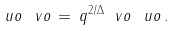Convert formula to latex. <formula><loc_0><loc_0><loc_500><loc_500>\ u o \, \ v o \, = \, q ^ { 2 / \Delta } \ v o \, \ u o \, .</formula> 